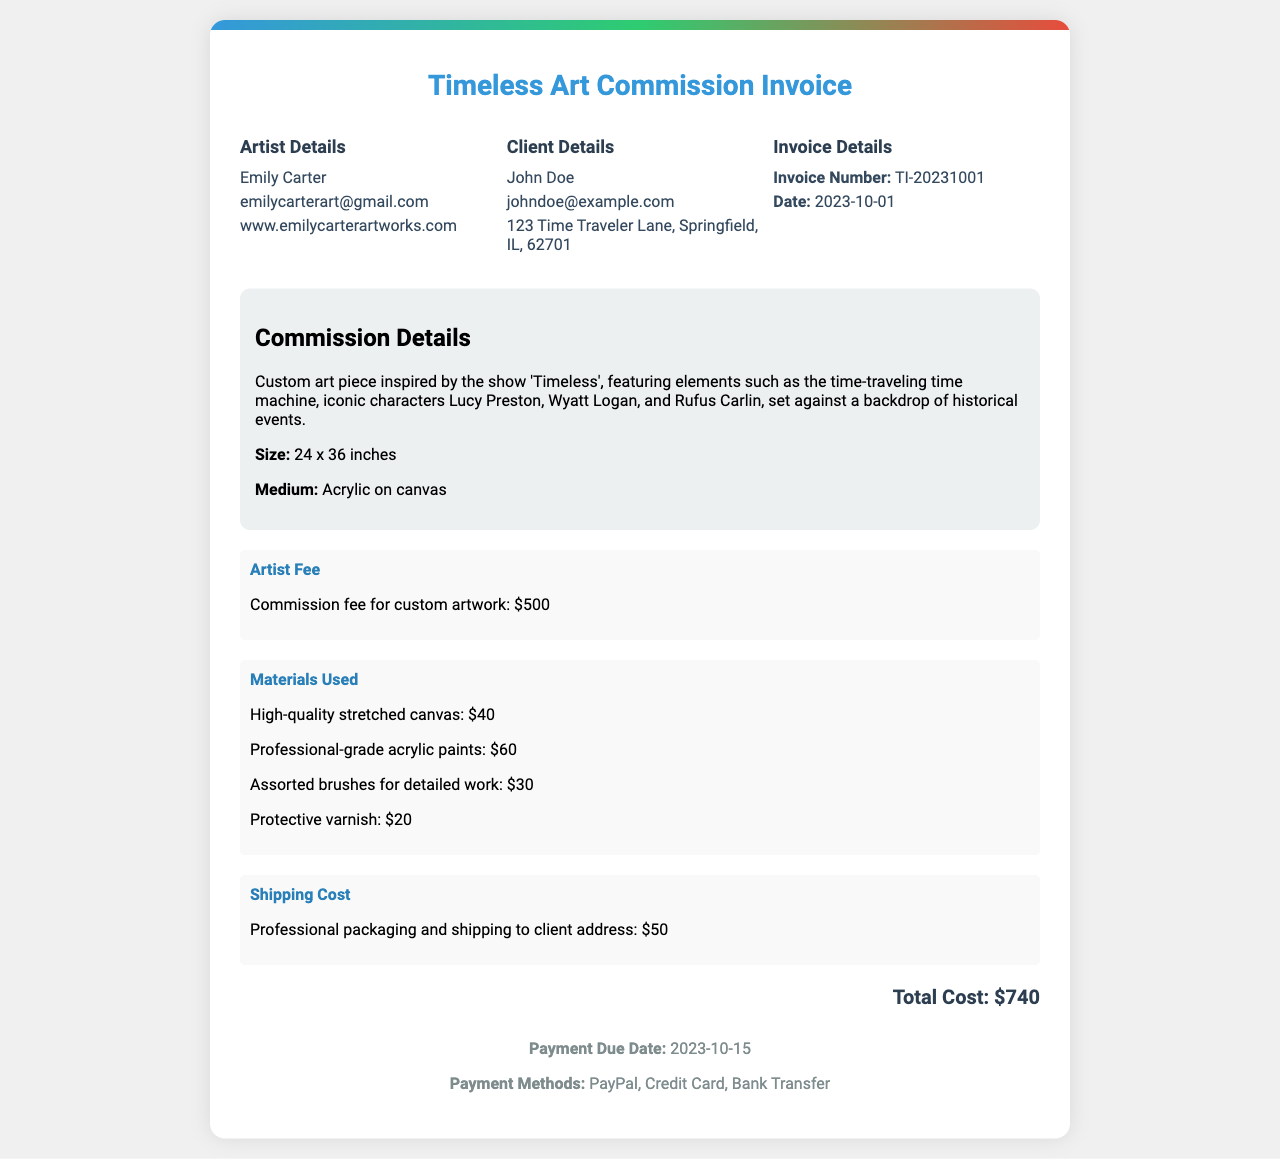What is the artist's name? The artist's name is mentioned in the document and is Emily Carter.
Answer: Emily Carter What is the size of the custom art piece? The size of the art piece is specified in the document as 24 x 36 inches.
Answer: 24 x 36 inches What is the artist's fee for the commission? The artist's fee is clearly stated in the document as $500.
Answer: $500 What is the total cost of the invoice? The total cost is the sum of all charges listed, which amounts to $740.
Answer: $740 What is the shipping cost? The shipping cost is detailed in the document as $50.
Answer: $50 What date is the payment due? The payment due date is provided in the document as 2023-10-15.
Answer: 2023-10-15 What materials were used for the commission? The document lists high-quality stretched canvas, professional-grade acrylic paints, assorted brushes, and protective varnish.
Answer: High-quality stretched canvas, professional-grade acrylic paints, assorted brushes, protective varnish In which medium was the art piece created? The medium for the custom art piece is specified in the invoice as acrylic on canvas.
Answer: Acrylic on canvas What are the payment methods listed? The payment methods are mentioned in the document and include PayPal, Credit Card, and Bank Transfer.
Answer: PayPal, Credit Card, Bank Transfer 